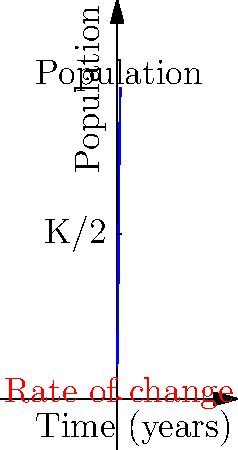As a veterinarian studying wildlife populations, you encounter a logistic growth model for a certain species. The blue curve represents the population over time, and the red curve shows the rate of change. At which point in time (in years) is the rate of population growth at its maximum? How does this relate to the carrying capacity (K) of the environment? To solve this problem, let's follow these steps:

1) In a logistic growth model, the rate of change is highest when the population is at half its carrying capacity (K/2).

2) From the graph, we can see that the carrying capacity (K) is the horizontal asymptote of the blue curve, which appears to be at 1000.

3) Therefore, K/2 = 500, which is represented by the dashed horizontal line on the graph.

4) The point where the population (blue curve) intersects this dashed line is the time at which the population is growing most rapidly.

5) This point also corresponds to the peak of the red curve, which represents the rate of change.

6) From the graph, we can estimate that this occurs at approximately 4 years.

7) This makes biological sense: when the population is at half the carrying capacity, resources are still plentiful, but there are also many individuals to reproduce, leading to the fastest growth rate.

8) After this point, the growth rate decreases as the population approaches the carrying capacity and resources become more limited.
Answer: 4 years; when population is K/2 (500) 